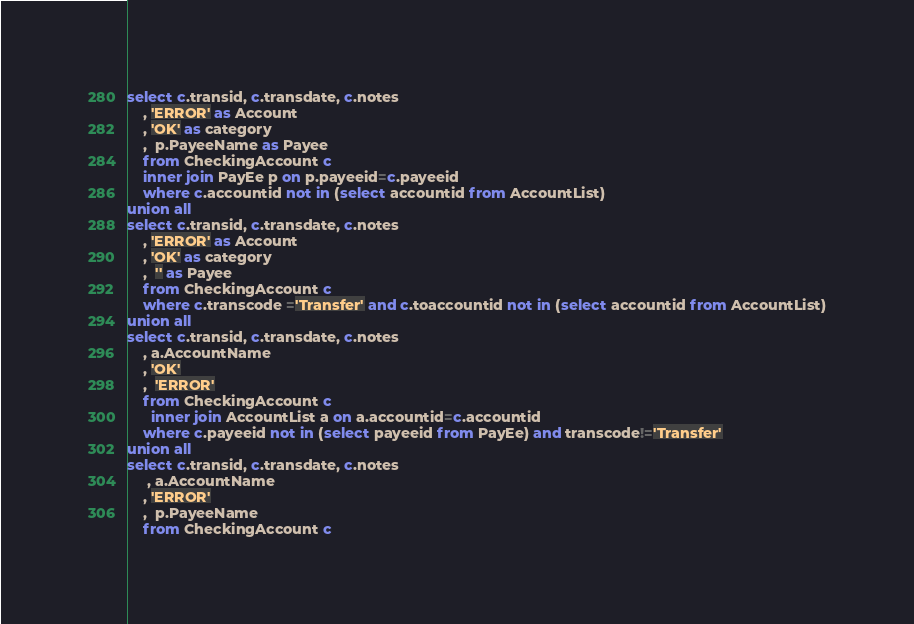Convert code to text. <code><loc_0><loc_0><loc_500><loc_500><_SQL_>select c.transid, c.transdate, c.notes
    , 'ERROR' as Account
    , 'OK' as category
    ,  p.PayeeName as Payee
    from CheckingAccount c
    inner join PayEe p on p.payeeid=c.payeeid
    where c.accountid not in (select accountid from AccountList)
union all
select c.transid, c.transdate, c.notes
    , 'ERROR' as Account
    , 'OK' as category
    ,  '' as Payee
    from CheckingAccount c
    where c.transcode ='Transfer' and c.toaccountid not in (select accountid from AccountList)
union all
select c.transid, c.transdate, c.notes
    , a.AccountName
    , 'OK' 
    ,  'ERROR' 
    from CheckingAccount c
      inner join AccountList a on a.accountid=c.accountid
    where c.payeeid not in (select payeeid from PayEe) and transcode!='Transfer'
union all
select c.transid, c.transdate, c.notes
     , a.AccountName
    , 'ERROR'
    ,  p.PayeeName
    from CheckingAccount c</code> 